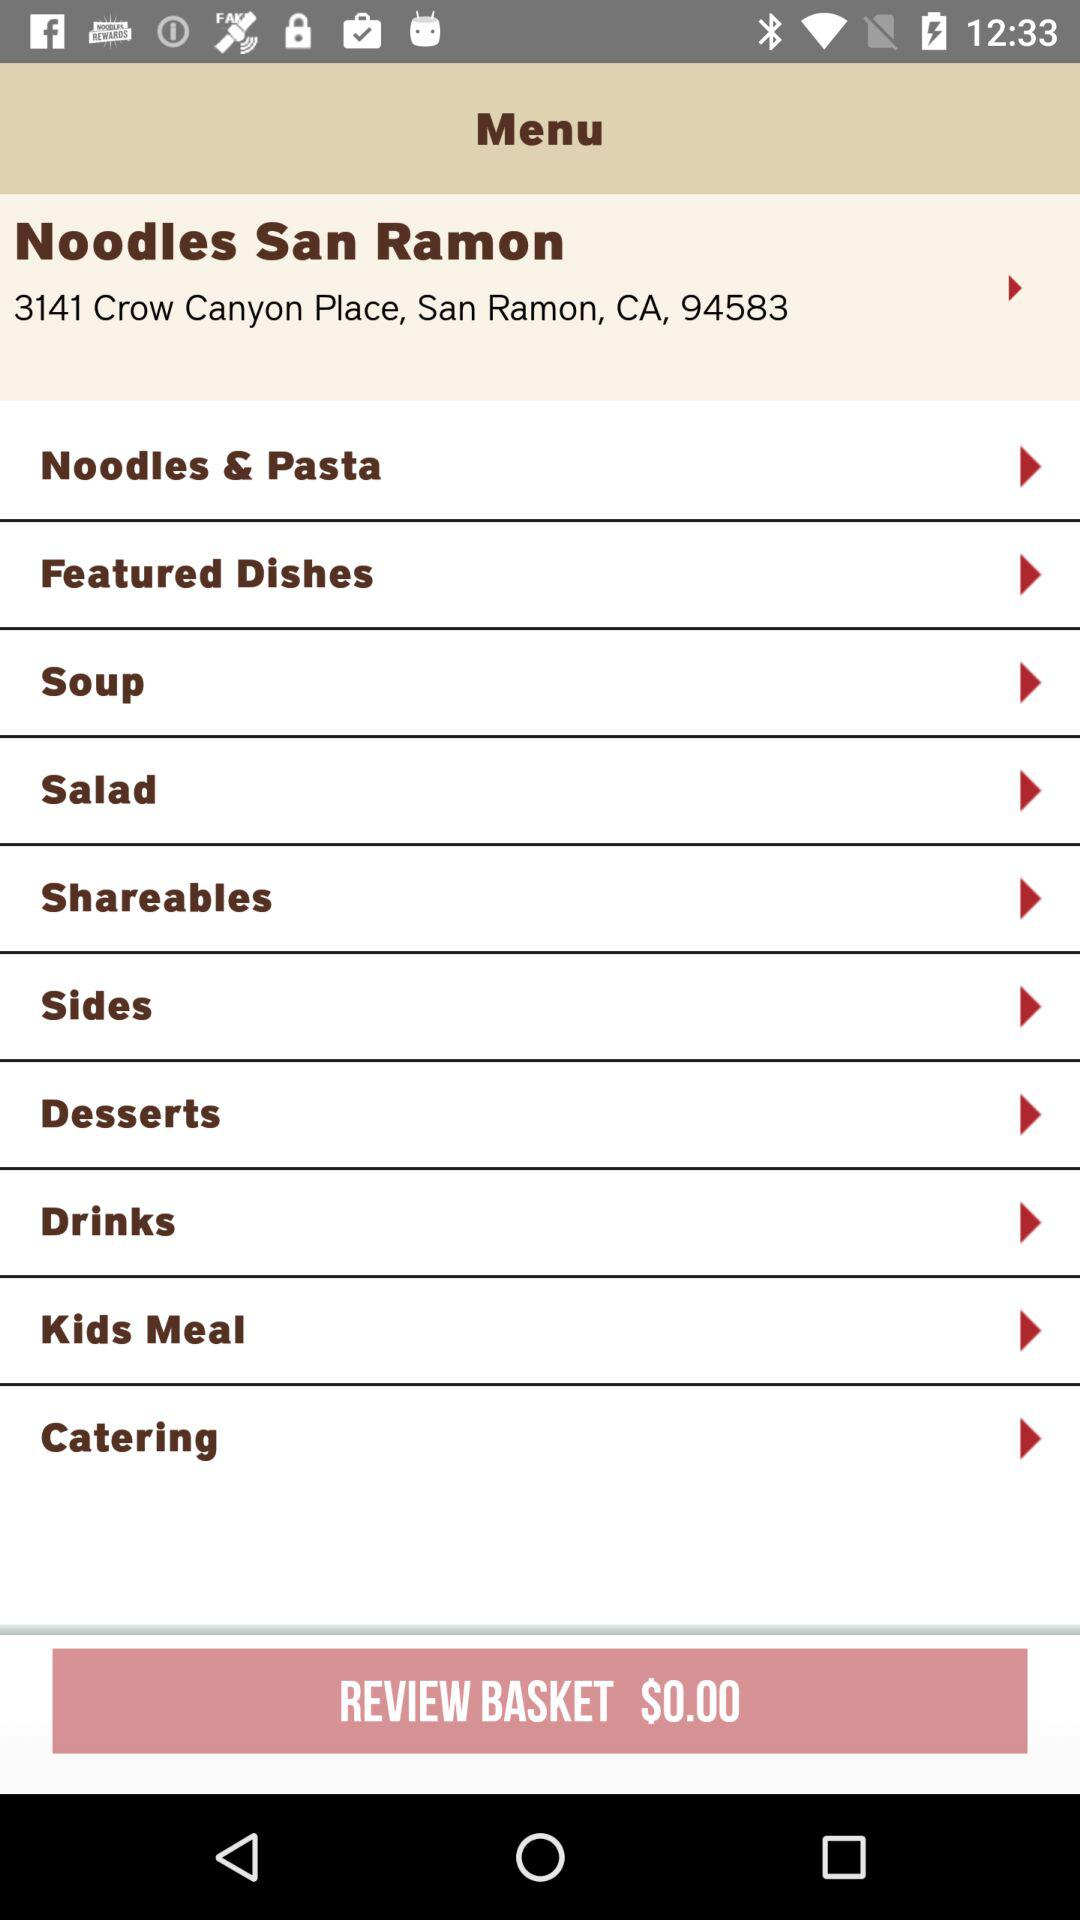What is the address of Noodles San Ramon? The address is 3141 Crow Canyon Place, San Ramon, CA, 94583. 